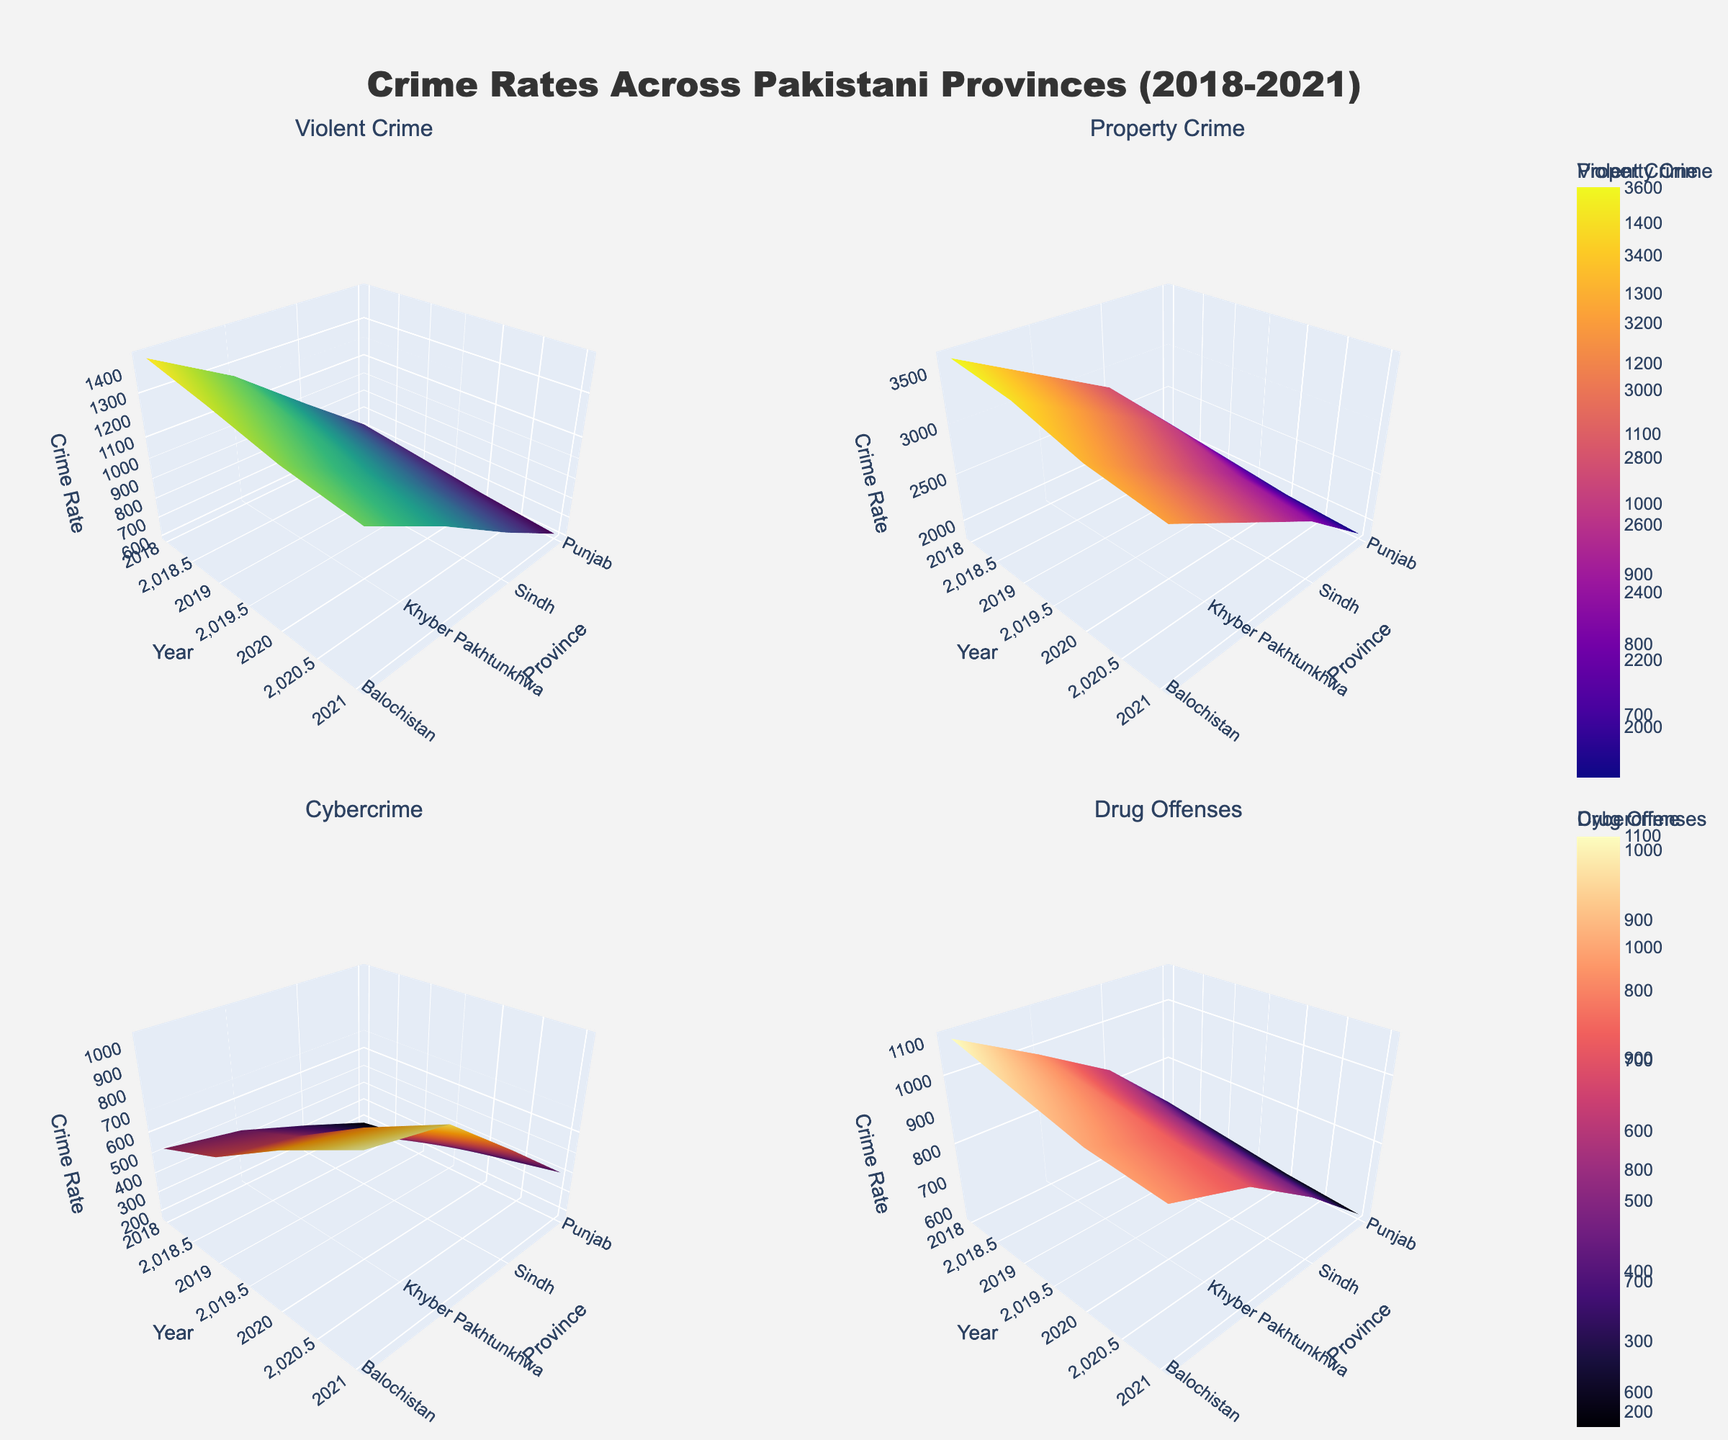What's the title of the figure? The title of the figure is displayed at the top center of the plot. It is written in larger font size compared to the rest of the text and describes what the plot is about.
Answer: Crime Rates Across Pakistani Provinces (2018-2021) How many provinces are represented in the figure? The horizontal axes of the surfaces show the provinces across all subplots. Counting these labels, you can see there are four provinces represented.
Answer: Four In which year did Punjab have the highest violent crime rate? To find the highest violent crime rate in Punjab, look at the surface plot of 'Violent Crime' and identify the year that corresponds to the highest peak in Punjab.
Answer: 2018 Which crime type had the highest overall value in Sindh in 2021? Next, you refer to the peaks on each surface plot for Sindh in the year 2021. Compare the z-axis values for all crime types for Sindh in that year to find the highest one.
Answer: Cybercrime What is the average property crime rate in Balochistan over the years 2018-2021? Locate the subplot for 'Property Crime' and Balochistan's trend line from 2018 to 2021. Average the crime rates: (2100 + 2000 + 1900 + 1850) / 4.
Answer: 1962.5 Did drug offenses increase or decrease in Khyber Pakhtunkhwa from 2018 to 2021? Track the surface plot for 'Drug Offenses' in Khyber Pakhtunkhwa from the year 2018 to 2021, observe whether the trend is upward or downward.
Answer: Decrease Which crime type shows the most significant decline in Punjab between any consecutive years? Analyze the declining slopes in Punjab's surface plots for all crime types from one year to the next, determining which crime type has the steepest decline.
Answer: Property Crime (2018 to 2019) In 2020, which province had the highest cybercrime rate? Look at the 'Cybercrime' surface plot and find the highest peak in the year 2020, then check the corresponding province on the x-axis.
Answer: Sindh How does the trend of violent crime in Sindh compare to that in Balochistan over the years? Compare the trend lines for violent crime in Sindh and Balochistan. Observe general patterns whether both increased, decreased, or remained stable over the years from 2018 to 2021.
Answer: Sindh decreased, while Balochistan also decreased, but Sindh had higher values throughout Which year saw the highest level of drug offenses in Punjab? Inspect the subplot for 'Drug Offenses' and identify the peak year for Punjab by following the trend.
Answer: 2018 